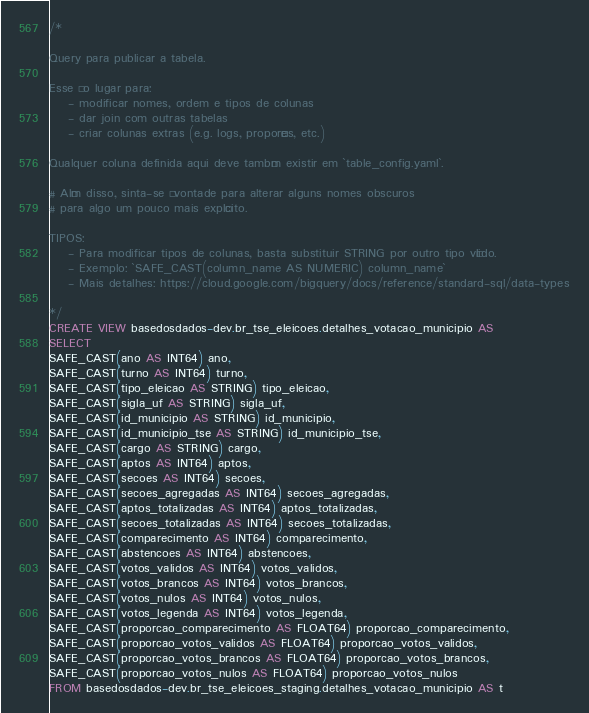<code> <loc_0><loc_0><loc_500><loc_500><_SQL_>/*

Query para publicar a tabela.

Esse é o lugar para:
    - modificar nomes, ordem e tipos de colunas
    - dar join com outras tabelas
    - criar colunas extras (e.g. logs, proporções, etc.)

Qualquer coluna definida aqui deve também existir em `table_config.yaml`.

# Além disso, sinta-se à vontade para alterar alguns nomes obscuros
# para algo um pouco mais explícito.

TIPOS:
    - Para modificar tipos de colunas, basta substituir STRING por outro tipo válido.
    - Exemplo: `SAFE_CAST(column_name AS NUMERIC) column_name`
    - Mais detalhes: https://cloud.google.com/bigquery/docs/reference/standard-sql/data-types

*/
CREATE VIEW basedosdados-dev.br_tse_eleicoes.detalhes_votacao_municipio AS
SELECT 
SAFE_CAST(ano AS INT64) ano,
SAFE_CAST(turno AS INT64) turno,
SAFE_CAST(tipo_eleicao AS STRING) tipo_eleicao,
SAFE_CAST(sigla_uf AS STRING) sigla_uf,
SAFE_CAST(id_municipio AS STRING) id_municipio,
SAFE_CAST(id_municipio_tse AS STRING) id_municipio_tse,
SAFE_CAST(cargo AS STRING) cargo,
SAFE_CAST(aptos AS INT64) aptos,
SAFE_CAST(secoes AS INT64) secoes,
SAFE_CAST(secoes_agregadas AS INT64) secoes_agregadas,
SAFE_CAST(aptos_totalizadas AS INT64) aptos_totalizadas,
SAFE_CAST(secoes_totalizadas AS INT64) secoes_totalizadas,
SAFE_CAST(comparecimento AS INT64) comparecimento,
SAFE_CAST(abstencoes AS INT64) abstencoes,
SAFE_CAST(votos_validos AS INT64) votos_validos,
SAFE_CAST(votos_brancos AS INT64) votos_brancos,
SAFE_CAST(votos_nulos AS INT64) votos_nulos,
SAFE_CAST(votos_legenda AS INT64) votos_legenda,
SAFE_CAST(proporcao_comparecimento AS FLOAT64) proporcao_comparecimento,
SAFE_CAST(proporcao_votos_validos AS FLOAT64) proporcao_votos_validos,
SAFE_CAST(proporcao_votos_brancos AS FLOAT64) proporcao_votos_brancos,
SAFE_CAST(proporcao_votos_nulos AS FLOAT64) proporcao_votos_nulos
FROM basedosdados-dev.br_tse_eleicoes_staging.detalhes_votacao_municipio AS t</code> 